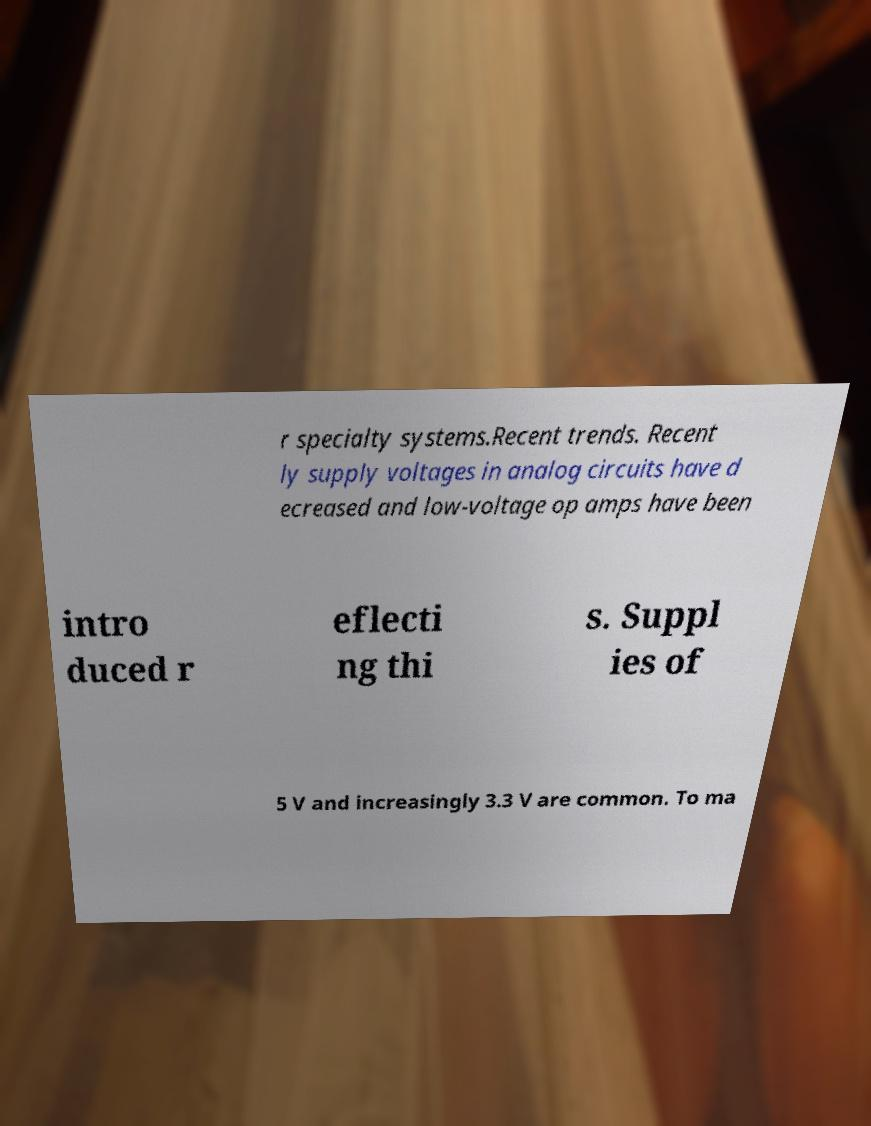For documentation purposes, I need the text within this image transcribed. Could you provide that? r specialty systems.Recent trends. Recent ly supply voltages in analog circuits have d ecreased and low-voltage op amps have been intro duced r eflecti ng thi s. Suppl ies of 5 V and increasingly 3.3 V are common. To ma 